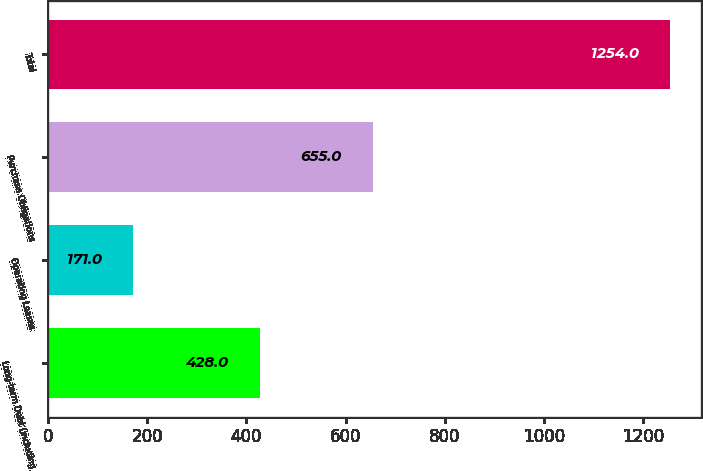Convert chart. <chart><loc_0><loc_0><loc_500><loc_500><bar_chart><fcel>Long-term Debt (including<fcel>Operating Leases<fcel>Purchase Obligations<fcel>Total<nl><fcel>428<fcel>171<fcel>655<fcel>1254<nl></chart> 